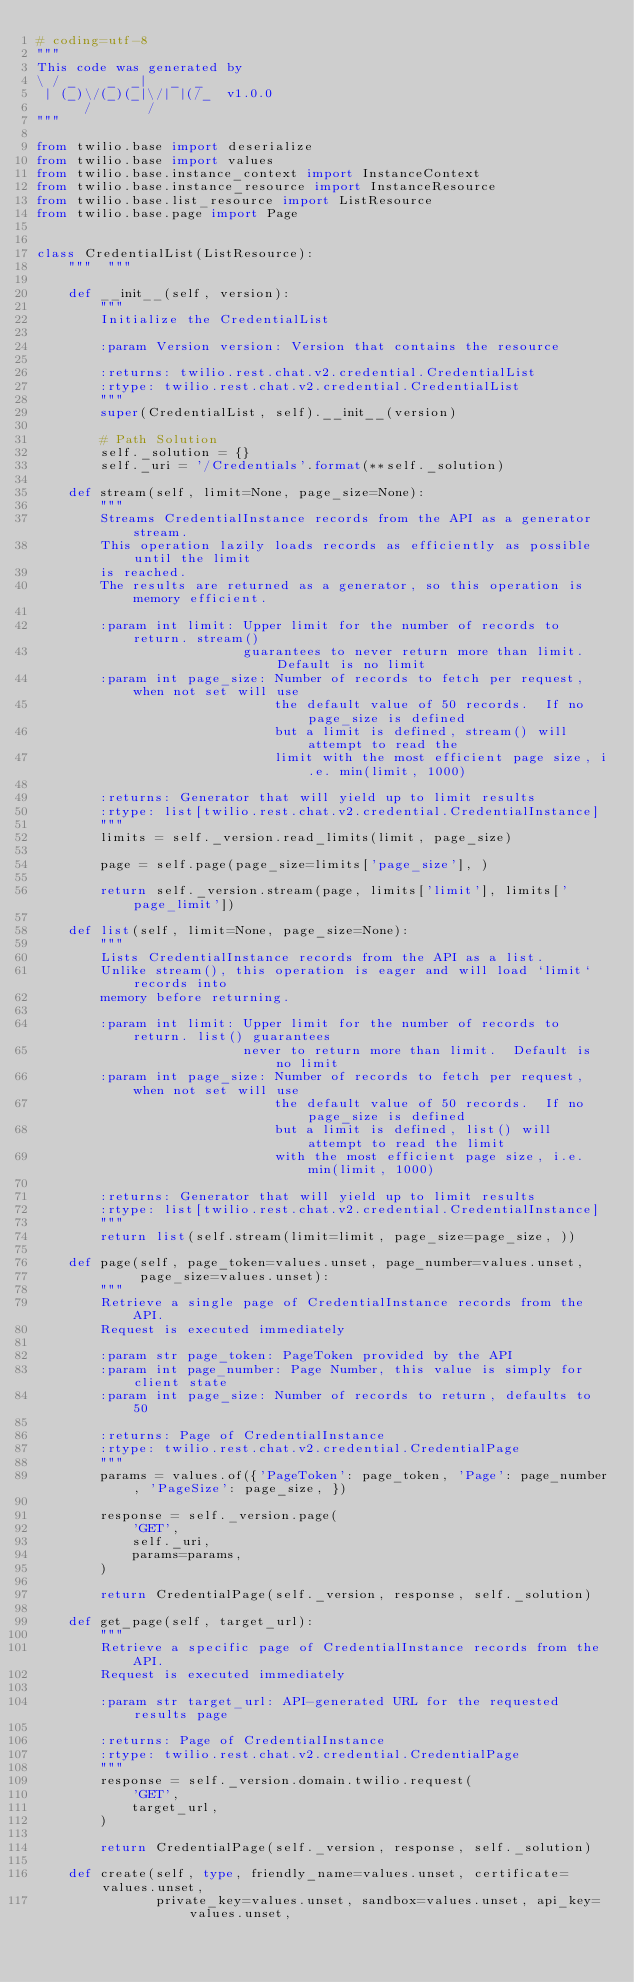<code> <loc_0><loc_0><loc_500><loc_500><_Python_># coding=utf-8
"""
This code was generated by
\ / _    _  _|   _  _
 | (_)\/(_)(_|\/| |(/_  v1.0.0
      /       /
"""

from twilio.base import deserialize
from twilio.base import values
from twilio.base.instance_context import InstanceContext
from twilio.base.instance_resource import InstanceResource
from twilio.base.list_resource import ListResource
from twilio.base.page import Page


class CredentialList(ListResource):
    """  """

    def __init__(self, version):
        """
        Initialize the CredentialList

        :param Version version: Version that contains the resource

        :returns: twilio.rest.chat.v2.credential.CredentialList
        :rtype: twilio.rest.chat.v2.credential.CredentialList
        """
        super(CredentialList, self).__init__(version)

        # Path Solution
        self._solution = {}
        self._uri = '/Credentials'.format(**self._solution)

    def stream(self, limit=None, page_size=None):
        """
        Streams CredentialInstance records from the API as a generator stream.
        This operation lazily loads records as efficiently as possible until the limit
        is reached.
        The results are returned as a generator, so this operation is memory efficient.

        :param int limit: Upper limit for the number of records to return. stream()
                          guarantees to never return more than limit.  Default is no limit
        :param int page_size: Number of records to fetch per request, when not set will use
                              the default value of 50 records.  If no page_size is defined
                              but a limit is defined, stream() will attempt to read the
                              limit with the most efficient page size, i.e. min(limit, 1000)

        :returns: Generator that will yield up to limit results
        :rtype: list[twilio.rest.chat.v2.credential.CredentialInstance]
        """
        limits = self._version.read_limits(limit, page_size)

        page = self.page(page_size=limits['page_size'], )

        return self._version.stream(page, limits['limit'], limits['page_limit'])

    def list(self, limit=None, page_size=None):
        """
        Lists CredentialInstance records from the API as a list.
        Unlike stream(), this operation is eager and will load `limit` records into
        memory before returning.

        :param int limit: Upper limit for the number of records to return. list() guarantees
                          never to return more than limit.  Default is no limit
        :param int page_size: Number of records to fetch per request, when not set will use
                              the default value of 50 records.  If no page_size is defined
                              but a limit is defined, list() will attempt to read the limit
                              with the most efficient page size, i.e. min(limit, 1000)

        :returns: Generator that will yield up to limit results
        :rtype: list[twilio.rest.chat.v2.credential.CredentialInstance]
        """
        return list(self.stream(limit=limit, page_size=page_size, ))

    def page(self, page_token=values.unset, page_number=values.unset,
             page_size=values.unset):
        """
        Retrieve a single page of CredentialInstance records from the API.
        Request is executed immediately

        :param str page_token: PageToken provided by the API
        :param int page_number: Page Number, this value is simply for client state
        :param int page_size: Number of records to return, defaults to 50

        :returns: Page of CredentialInstance
        :rtype: twilio.rest.chat.v2.credential.CredentialPage
        """
        params = values.of({'PageToken': page_token, 'Page': page_number, 'PageSize': page_size, })

        response = self._version.page(
            'GET',
            self._uri,
            params=params,
        )

        return CredentialPage(self._version, response, self._solution)

    def get_page(self, target_url):
        """
        Retrieve a specific page of CredentialInstance records from the API.
        Request is executed immediately

        :param str target_url: API-generated URL for the requested results page

        :returns: Page of CredentialInstance
        :rtype: twilio.rest.chat.v2.credential.CredentialPage
        """
        response = self._version.domain.twilio.request(
            'GET',
            target_url,
        )

        return CredentialPage(self._version, response, self._solution)

    def create(self, type, friendly_name=values.unset, certificate=values.unset,
               private_key=values.unset, sandbox=values.unset, api_key=values.unset,</code> 